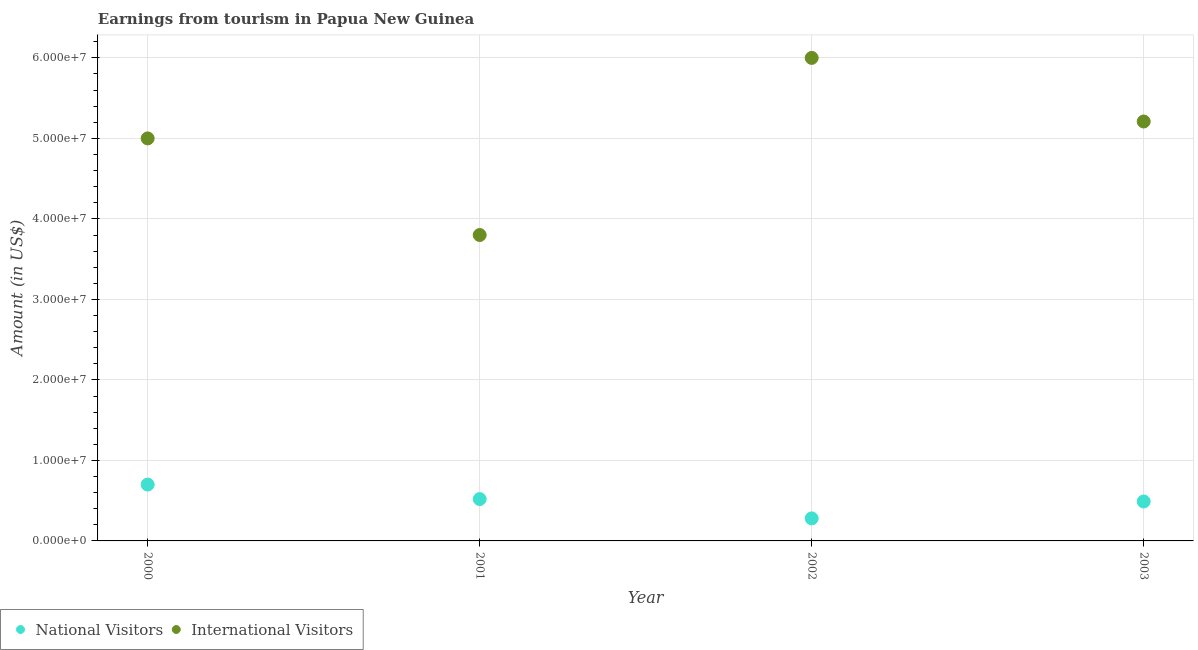How many different coloured dotlines are there?
Provide a short and direct response. 2. Is the number of dotlines equal to the number of legend labels?
Provide a succinct answer. Yes. What is the amount earned from international visitors in 2003?
Your response must be concise. 5.21e+07. Across all years, what is the maximum amount earned from national visitors?
Make the answer very short. 7.00e+06. Across all years, what is the minimum amount earned from international visitors?
Give a very brief answer. 3.80e+07. What is the total amount earned from national visitors in the graph?
Provide a short and direct response. 1.99e+07. What is the difference between the amount earned from national visitors in 2001 and that in 2003?
Make the answer very short. 3.00e+05. What is the difference between the amount earned from international visitors in 2002 and the amount earned from national visitors in 2000?
Make the answer very short. 5.30e+07. What is the average amount earned from international visitors per year?
Offer a very short reply. 5.00e+07. In the year 2001, what is the difference between the amount earned from international visitors and amount earned from national visitors?
Offer a terse response. 3.28e+07. What is the ratio of the amount earned from national visitors in 2000 to that in 2003?
Your answer should be very brief. 1.43. What is the difference between the highest and the second highest amount earned from international visitors?
Provide a succinct answer. 7.90e+06. What is the difference between the highest and the lowest amount earned from national visitors?
Offer a terse response. 4.20e+06. In how many years, is the amount earned from national visitors greater than the average amount earned from national visitors taken over all years?
Keep it short and to the point. 2. Is the sum of the amount earned from national visitors in 2001 and 2002 greater than the maximum amount earned from international visitors across all years?
Your answer should be very brief. No. Does the amount earned from national visitors monotonically increase over the years?
Your answer should be very brief. No. Is the amount earned from national visitors strictly less than the amount earned from international visitors over the years?
Keep it short and to the point. Yes. How many dotlines are there?
Your answer should be compact. 2. Are the values on the major ticks of Y-axis written in scientific E-notation?
Make the answer very short. Yes. Does the graph contain any zero values?
Offer a terse response. No. Where does the legend appear in the graph?
Offer a terse response. Bottom left. How are the legend labels stacked?
Offer a very short reply. Horizontal. What is the title of the graph?
Your response must be concise. Earnings from tourism in Papua New Guinea. Does "Netherlands" appear as one of the legend labels in the graph?
Make the answer very short. No. What is the label or title of the Y-axis?
Keep it short and to the point. Amount (in US$). What is the Amount (in US$) of International Visitors in 2000?
Make the answer very short. 5.00e+07. What is the Amount (in US$) in National Visitors in 2001?
Your response must be concise. 5.20e+06. What is the Amount (in US$) of International Visitors in 2001?
Provide a succinct answer. 3.80e+07. What is the Amount (in US$) in National Visitors in 2002?
Your answer should be compact. 2.80e+06. What is the Amount (in US$) in International Visitors in 2002?
Provide a short and direct response. 6.00e+07. What is the Amount (in US$) in National Visitors in 2003?
Make the answer very short. 4.90e+06. What is the Amount (in US$) of International Visitors in 2003?
Keep it short and to the point. 5.21e+07. Across all years, what is the maximum Amount (in US$) of National Visitors?
Ensure brevity in your answer.  7.00e+06. Across all years, what is the maximum Amount (in US$) in International Visitors?
Keep it short and to the point. 6.00e+07. Across all years, what is the minimum Amount (in US$) of National Visitors?
Your response must be concise. 2.80e+06. Across all years, what is the minimum Amount (in US$) in International Visitors?
Make the answer very short. 3.80e+07. What is the total Amount (in US$) in National Visitors in the graph?
Provide a short and direct response. 1.99e+07. What is the total Amount (in US$) of International Visitors in the graph?
Your answer should be compact. 2.00e+08. What is the difference between the Amount (in US$) in National Visitors in 2000 and that in 2001?
Your answer should be compact. 1.80e+06. What is the difference between the Amount (in US$) of National Visitors in 2000 and that in 2002?
Make the answer very short. 4.20e+06. What is the difference between the Amount (in US$) in International Visitors in 2000 and that in 2002?
Give a very brief answer. -1.00e+07. What is the difference between the Amount (in US$) of National Visitors in 2000 and that in 2003?
Ensure brevity in your answer.  2.10e+06. What is the difference between the Amount (in US$) of International Visitors in 2000 and that in 2003?
Make the answer very short. -2.10e+06. What is the difference between the Amount (in US$) of National Visitors in 2001 and that in 2002?
Provide a short and direct response. 2.40e+06. What is the difference between the Amount (in US$) in International Visitors in 2001 and that in 2002?
Offer a terse response. -2.20e+07. What is the difference between the Amount (in US$) in National Visitors in 2001 and that in 2003?
Make the answer very short. 3.00e+05. What is the difference between the Amount (in US$) in International Visitors in 2001 and that in 2003?
Offer a terse response. -1.41e+07. What is the difference between the Amount (in US$) of National Visitors in 2002 and that in 2003?
Ensure brevity in your answer.  -2.10e+06. What is the difference between the Amount (in US$) in International Visitors in 2002 and that in 2003?
Provide a short and direct response. 7.90e+06. What is the difference between the Amount (in US$) of National Visitors in 2000 and the Amount (in US$) of International Visitors in 2001?
Offer a very short reply. -3.10e+07. What is the difference between the Amount (in US$) of National Visitors in 2000 and the Amount (in US$) of International Visitors in 2002?
Offer a very short reply. -5.30e+07. What is the difference between the Amount (in US$) of National Visitors in 2000 and the Amount (in US$) of International Visitors in 2003?
Provide a short and direct response. -4.51e+07. What is the difference between the Amount (in US$) in National Visitors in 2001 and the Amount (in US$) in International Visitors in 2002?
Offer a terse response. -5.48e+07. What is the difference between the Amount (in US$) of National Visitors in 2001 and the Amount (in US$) of International Visitors in 2003?
Make the answer very short. -4.69e+07. What is the difference between the Amount (in US$) in National Visitors in 2002 and the Amount (in US$) in International Visitors in 2003?
Make the answer very short. -4.93e+07. What is the average Amount (in US$) in National Visitors per year?
Your answer should be very brief. 4.98e+06. What is the average Amount (in US$) in International Visitors per year?
Provide a succinct answer. 5.00e+07. In the year 2000, what is the difference between the Amount (in US$) of National Visitors and Amount (in US$) of International Visitors?
Provide a short and direct response. -4.30e+07. In the year 2001, what is the difference between the Amount (in US$) in National Visitors and Amount (in US$) in International Visitors?
Your response must be concise. -3.28e+07. In the year 2002, what is the difference between the Amount (in US$) in National Visitors and Amount (in US$) in International Visitors?
Offer a very short reply. -5.72e+07. In the year 2003, what is the difference between the Amount (in US$) of National Visitors and Amount (in US$) of International Visitors?
Make the answer very short. -4.72e+07. What is the ratio of the Amount (in US$) of National Visitors in 2000 to that in 2001?
Ensure brevity in your answer.  1.35. What is the ratio of the Amount (in US$) in International Visitors in 2000 to that in 2001?
Your response must be concise. 1.32. What is the ratio of the Amount (in US$) in National Visitors in 2000 to that in 2002?
Your response must be concise. 2.5. What is the ratio of the Amount (in US$) in International Visitors in 2000 to that in 2002?
Your response must be concise. 0.83. What is the ratio of the Amount (in US$) of National Visitors in 2000 to that in 2003?
Keep it short and to the point. 1.43. What is the ratio of the Amount (in US$) in International Visitors in 2000 to that in 2003?
Make the answer very short. 0.96. What is the ratio of the Amount (in US$) in National Visitors in 2001 to that in 2002?
Give a very brief answer. 1.86. What is the ratio of the Amount (in US$) of International Visitors in 2001 to that in 2002?
Your answer should be very brief. 0.63. What is the ratio of the Amount (in US$) in National Visitors in 2001 to that in 2003?
Keep it short and to the point. 1.06. What is the ratio of the Amount (in US$) in International Visitors in 2001 to that in 2003?
Your response must be concise. 0.73. What is the ratio of the Amount (in US$) of National Visitors in 2002 to that in 2003?
Your response must be concise. 0.57. What is the ratio of the Amount (in US$) of International Visitors in 2002 to that in 2003?
Give a very brief answer. 1.15. What is the difference between the highest and the second highest Amount (in US$) of National Visitors?
Offer a terse response. 1.80e+06. What is the difference between the highest and the second highest Amount (in US$) of International Visitors?
Offer a terse response. 7.90e+06. What is the difference between the highest and the lowest Amount (in US$) of National Visitors?
Provide a short and direct response. 4.20e+06. What is the difference between the highest and the lowest Amount (in US$) in International Visitors?
Your response must be concise. 2.20e+07. 